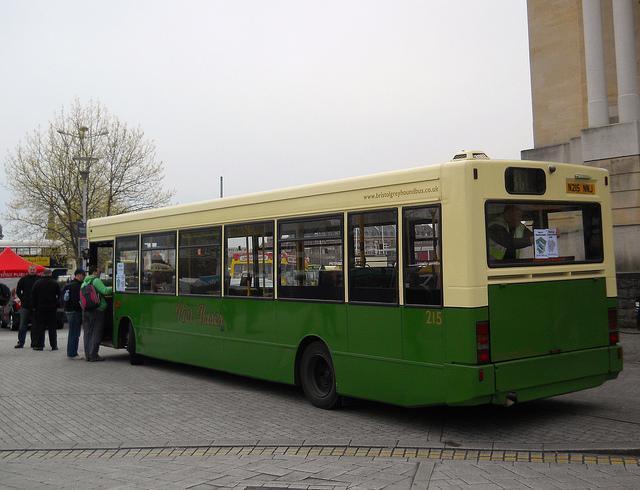In which country is this bus taking on passengers?
Choose the right answer and clarify with the format: 'Answer: answer
Rationale: rationale.'
Options: Japan, england, united states, fiji. Answer: england.
Rationale: It has a co.uk website address on the bus and uncommon to see that anywhere other than the uk. 